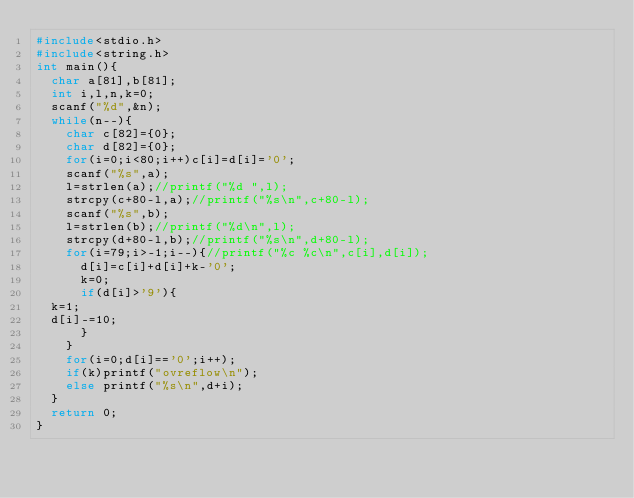Convert code to text. <code><loc_0><loc_0><loc_500><loc_500><_C_>#include<stdio.h>
#include<string.h>
int main(){
  char a[81],b[81];
  int i,l,n,k=0;
  scanf("%d",&n);
  while(n--){
    char c[82]={0};
    char d[82]={0};
    for(i=0;i<80;i++)c[i]=d[i]='0';
    scanf("%s",a);
    l=strlen(a);//printf("%d ",l);
    strcpy(c+80-l,a);//printf("%s\n",c+80-l);
    scanf("%s",b);
    l=strlen(b);//printf("%d\n",l);
    strcpy(d+80-l,b);//printf("%s\n",d+80-l);
    for(i=79;i>-1;i--){//printf("%c %c\n",c[i],d[i]);
      d[i]=c[i]+d[i]+k-'0';
      k=0;
      if(d[i]>'9'){
	k=1;
	d[i]-=10;
      }
    }
    for(i=0;d[i]=='0';i++);
    if(k)printf("ovreflow\n");
    else printf("%s\n",d+i);
  }
  return 0;
}</code> 